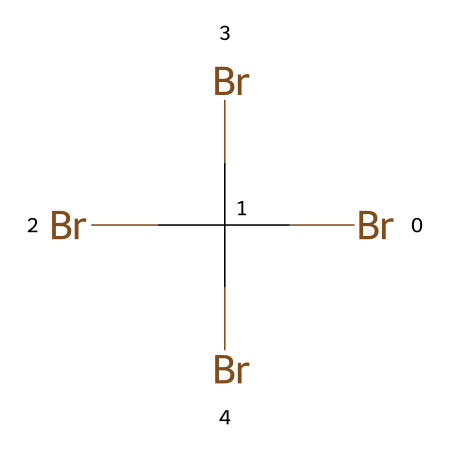What is the total number of bromine atoms in the chemical structure? The SMILES notation BrC(Br)(Br)Br indicates that there are four bromine atoms connected to a carbon atom. Therefore, counting the number of Br symbols gives us the total.
Answer: four What is the chemical bonding type present in this compound? The compound has carbon bonded to four bromine atoms, indicating that it involves covalent bonding, characteristic of organic compounds with halogens.
Answer: covalent How many bonds are formed between the carbon atom and bromine atoms? Each bromine atom forms a single bond with the carbon atom. Since there are four bromine atoms, this results in four single bonds between the carbon and bromine in the structure.
Answer: four Is the chemical structure likely to be a flame retardant? The presence of multiple bromine atoms linked to carbon suggests properties that can inhibit flame propagation, making it characteristic of many flame retardants.
Answer: yes What is the role of bromine atoms in the flame retardant properties of the chemical? Bromine atoms are known for forming stable radicals that can interrupt combustion reactions, thus enhancing flame retardancy in materials where they are incorporated.
Answer: interrupt combustion Does this chemical have a symmetrical structure? The chemical structure shows a carbon atom at the center with four bromine atoms symmetrically arranged around it, indicating a symmetrical structure.
Answer: yes 